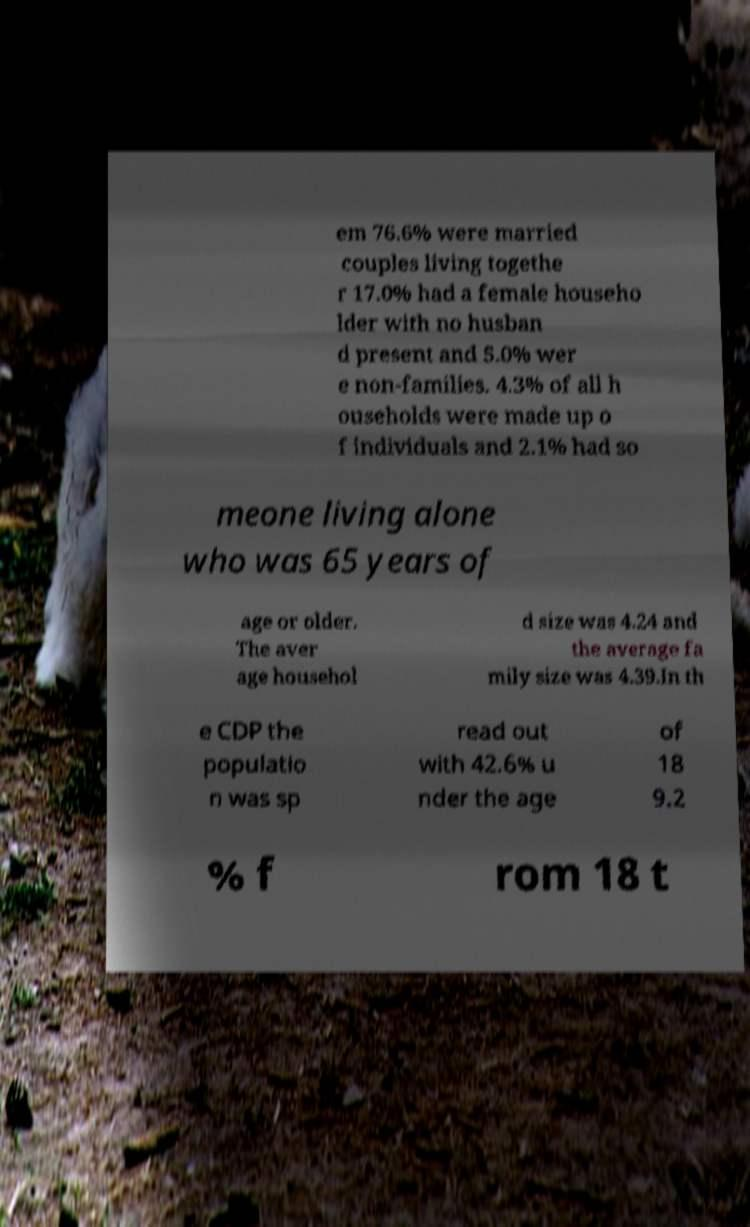Please identify and transcribe the text found in this image. em 76.6% were married couples living togethe r 17.0% had a female househo lder with no husban d present and 5.0% wer e non-families. 4.3% of all h ouseholds were made up o f individuals and 2.1% had so meone living alone who was 65 years of age or older. The aver age househol d size was 4.24 and the average fa mily size was 4.39.In th e CDP the populatio n was sp read out with 42.6% u nder the age of 18 9.2 % f rom 18 t 